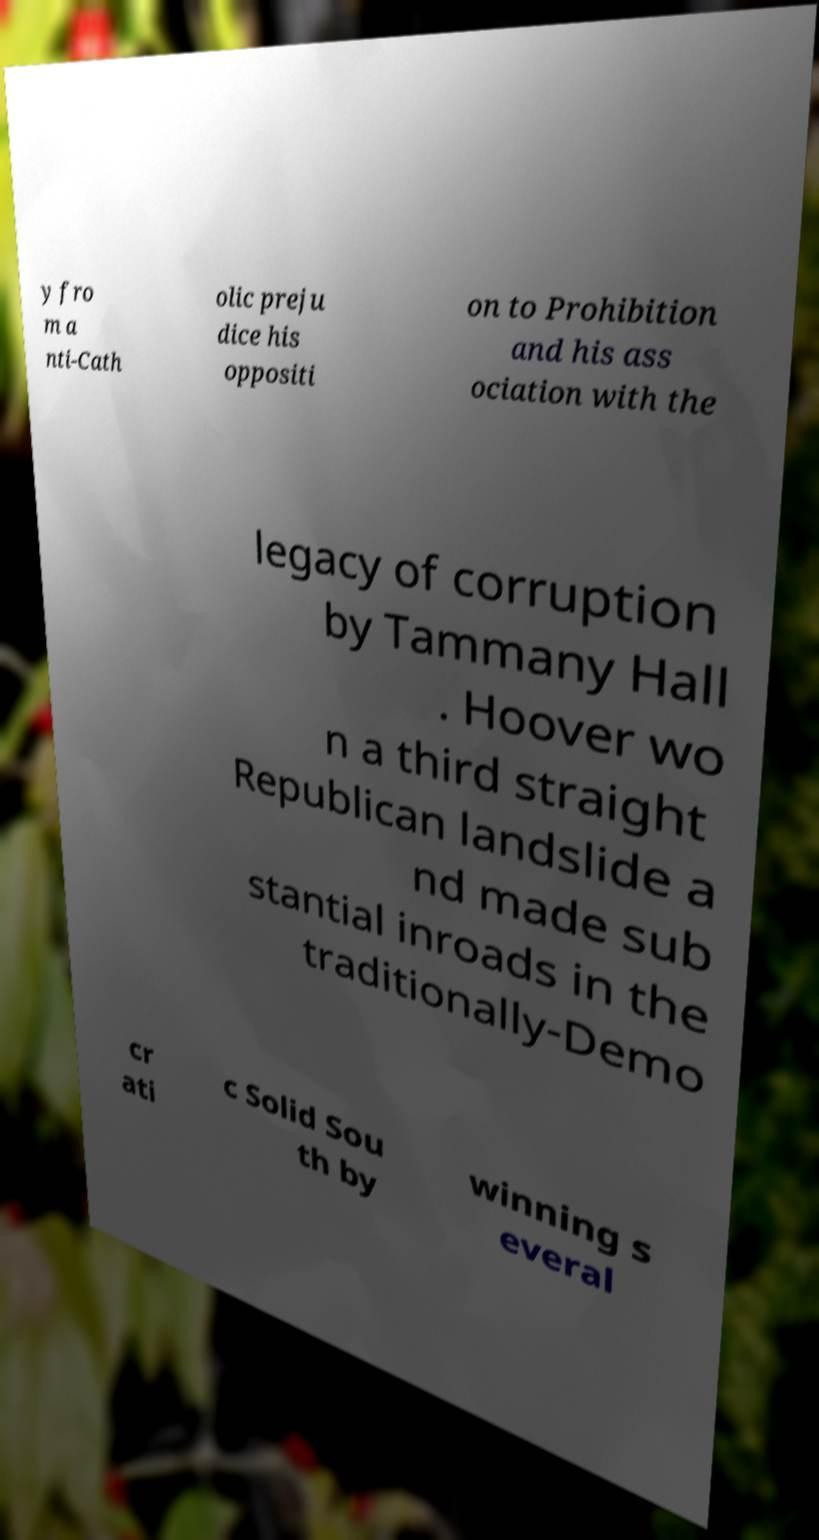Could you extract and type out the text from this image? y fro m a nti-Cath olic preju dice his oppositi on to Prohibition and his ass ociation with the legacy of corruption by Tammany Hall . Hoover wo n a third straight Republican landslide a nd made sub stantial inroads in the traditionally-Demo cr ati c Solid Sou th by winning s everal 